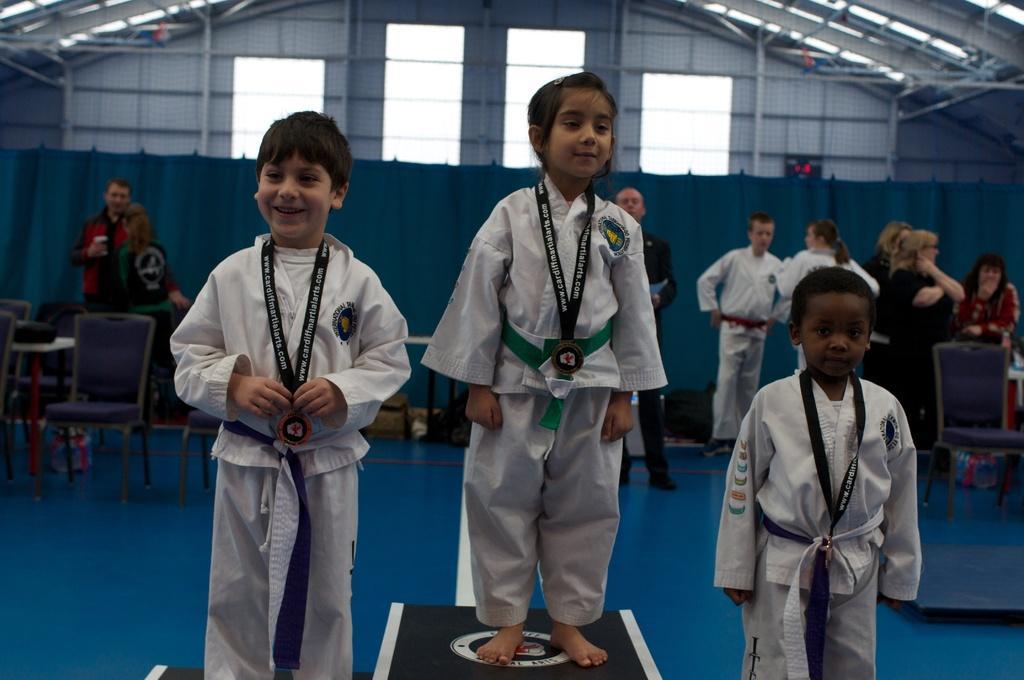Can you describe this image briefly? In this image we can see three kids wearing white color dress standing on block and in the background of the image there are some persons standing, there are some chairs, tables and there is a wall. 